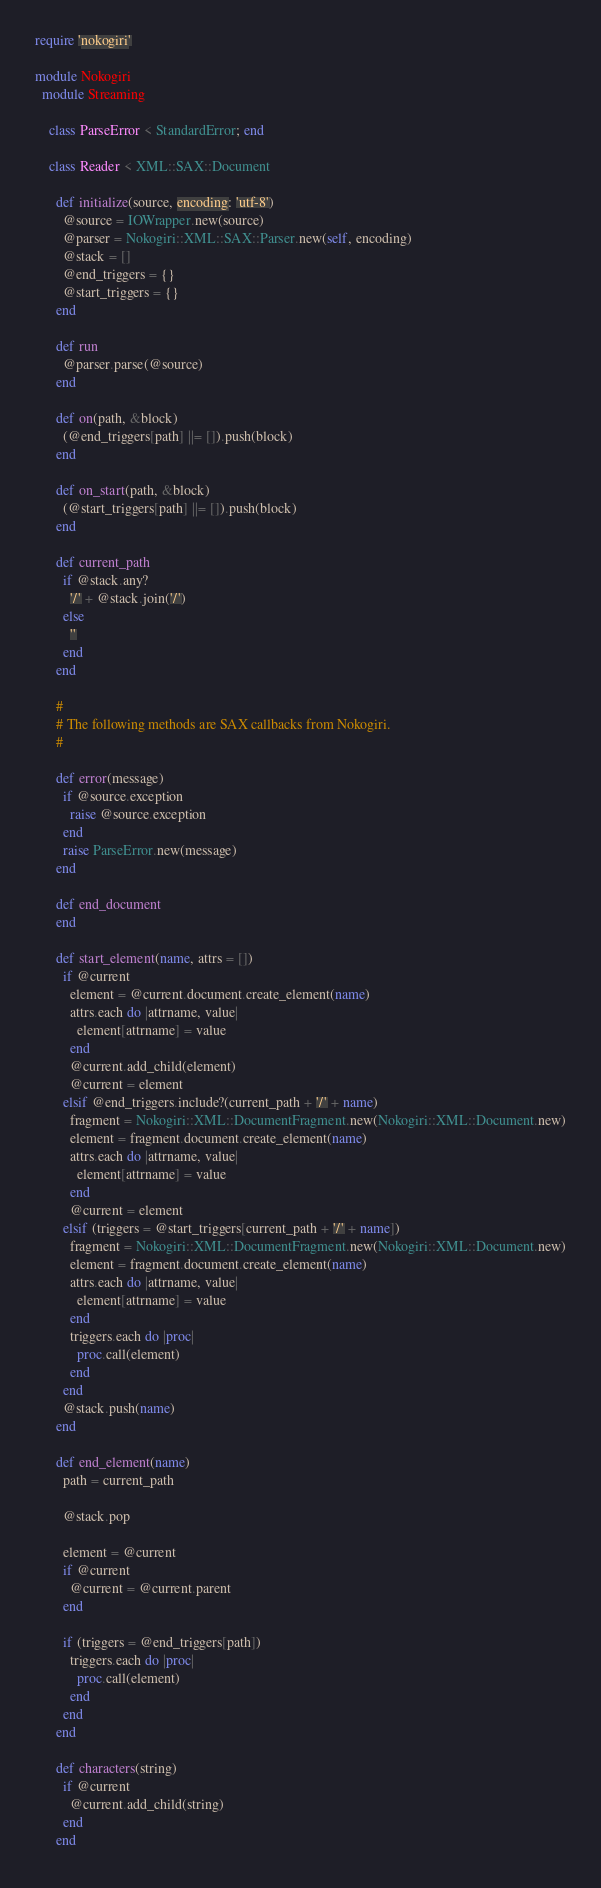Convert code to text. <code><loc_0><loc_0><loc_500><loc_500><_Ruby_>require 'nokogiri'

module Nokogiri
  module Streaming

    class ParseError < StandardError; end

    class Reader < XML::SAX::Document

      def initialize(source, encoding: 'utf-8')
        @source = IOWrapper.new(source)
        @parser = Nokogiri::XML::SAX::Parser.new(self, encoding)
        @stack = []
        @end_triggers = {}
        @start_triggers = {}
      end

      def run
        @parser.parse(@source)
      end

      def on(path, &block)
        (@end_triggers[path] ||= []).push(block)
      end

      def on_start(path, &block)
        (@start_triggers[path] ||= []).push(block)
      end

      def current_path
        if @stack.any?
          '/' + @stack.join('/')
        else
          ''
        end
      end

      #
      # The following methods are SAX callbacks from Nokogiri.
      #

      def error(message)
        if @source.exception
          raise @source.exception
        end
        raise ParseError.new(message)
      end

      def end_document
      end

      def start_element(name, attrs = [])
        if @current
          element = @current.document.create_element(name)
          attrs.each do |attrname, value|
            element[attrname] = value
          end
          @current.add_child(element)
          @current = element
        elsif @end_triggers.include?(current_path + '/' + name)
          fragment = Nokogiri::XML::DocumentFragment.new(Nokogiri::XML::Document.new)
          element = fragment.document.create_element(name)
          attrs.each do |attrname, value|
            element[attrname] = value
          end
          @current = element
        elsif (triggers = @start_triggers[current_path + '/' + name])
          fragment = Nokogiri::XML::DocumentFragment.new(Nokogiri::XML::Document.new)
          element = fragment.document.create_element(name)
          attrs.each do |attrname, value|
            element[attrname] = value
          end
          triggers.each do |proc|
            proc.call(element)
          end
        end
        @stack.push(name)
      end

      def end_element(name)
        path = current_path

        @stack.pop

        element = @current
        if @current
          @current = @current.parent
        end

        if (triggers = @end_triggers[path])
          triggers.each do |proc|
            proc.call(element)
          end
        end
      end

      def characters(string)
        if @current
          @current.add_child(string)
        end
      end
</code> 